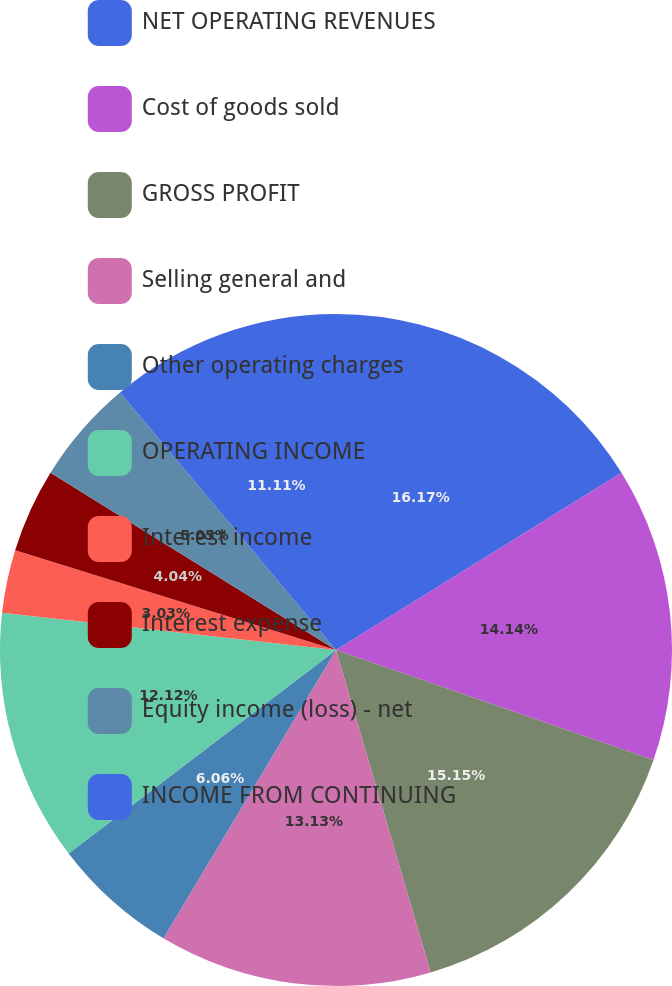Convert chart to OTSL. <chart><loc_0><loc_0><loc_500><loc_500><pie_chart><fcel>NET OPERATING REVENUES<fcel>Cost of goods sold<fcel>GROSS PROFIT<fcel>Selling general and<fcel>Other operating charges<fcel>OPERATING INCOME<fcel>Interest income<fcel>Interest expense<fcel>Equity income (loss) - net<fcel>INCOME FROM CONTINUING<nl><fcel>16.16%<fcel>14.14%<fcel>15.15%<fcel>13.13%<fcel>6.06%<fcel>12.12%<fcel>3.03%<fcel>4.04%<fcel>5.05%<fcel>11.11%<nl></chart> 